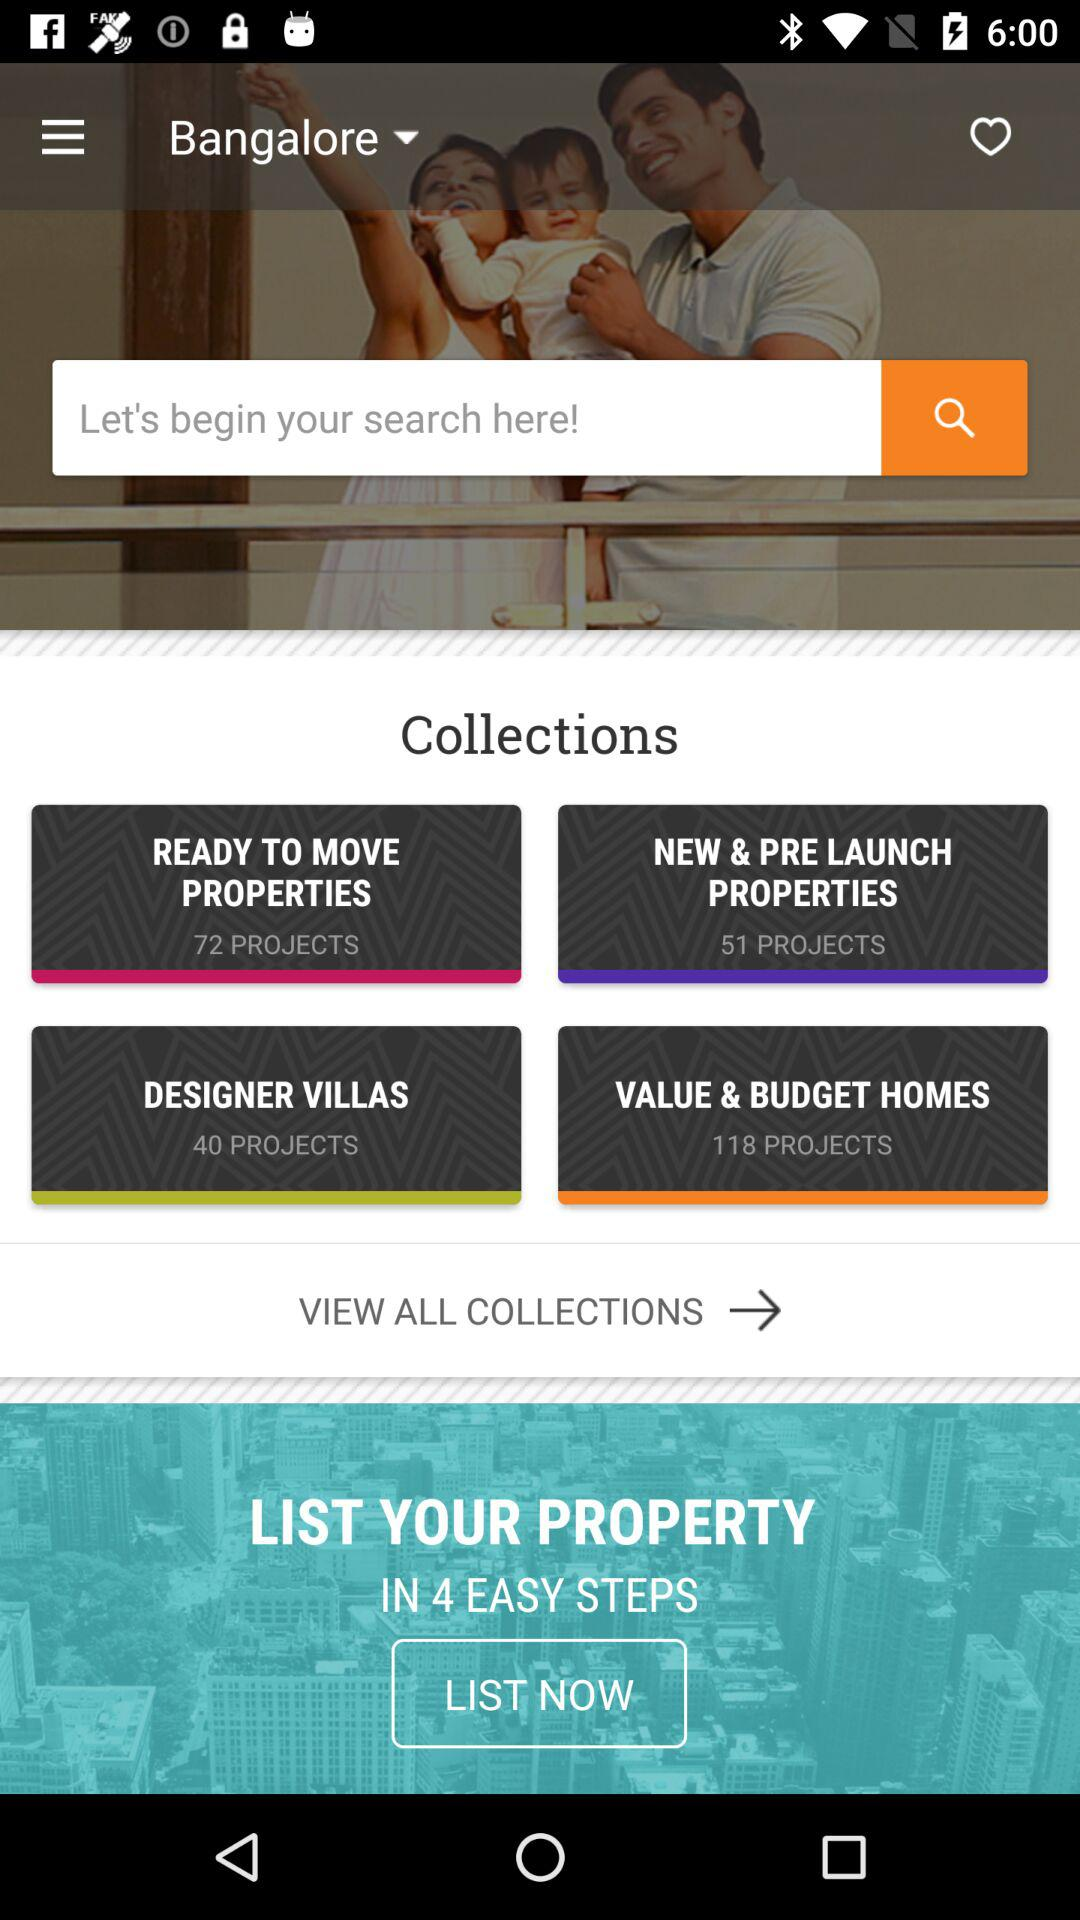What is the given location? The location is "Bangalore". 